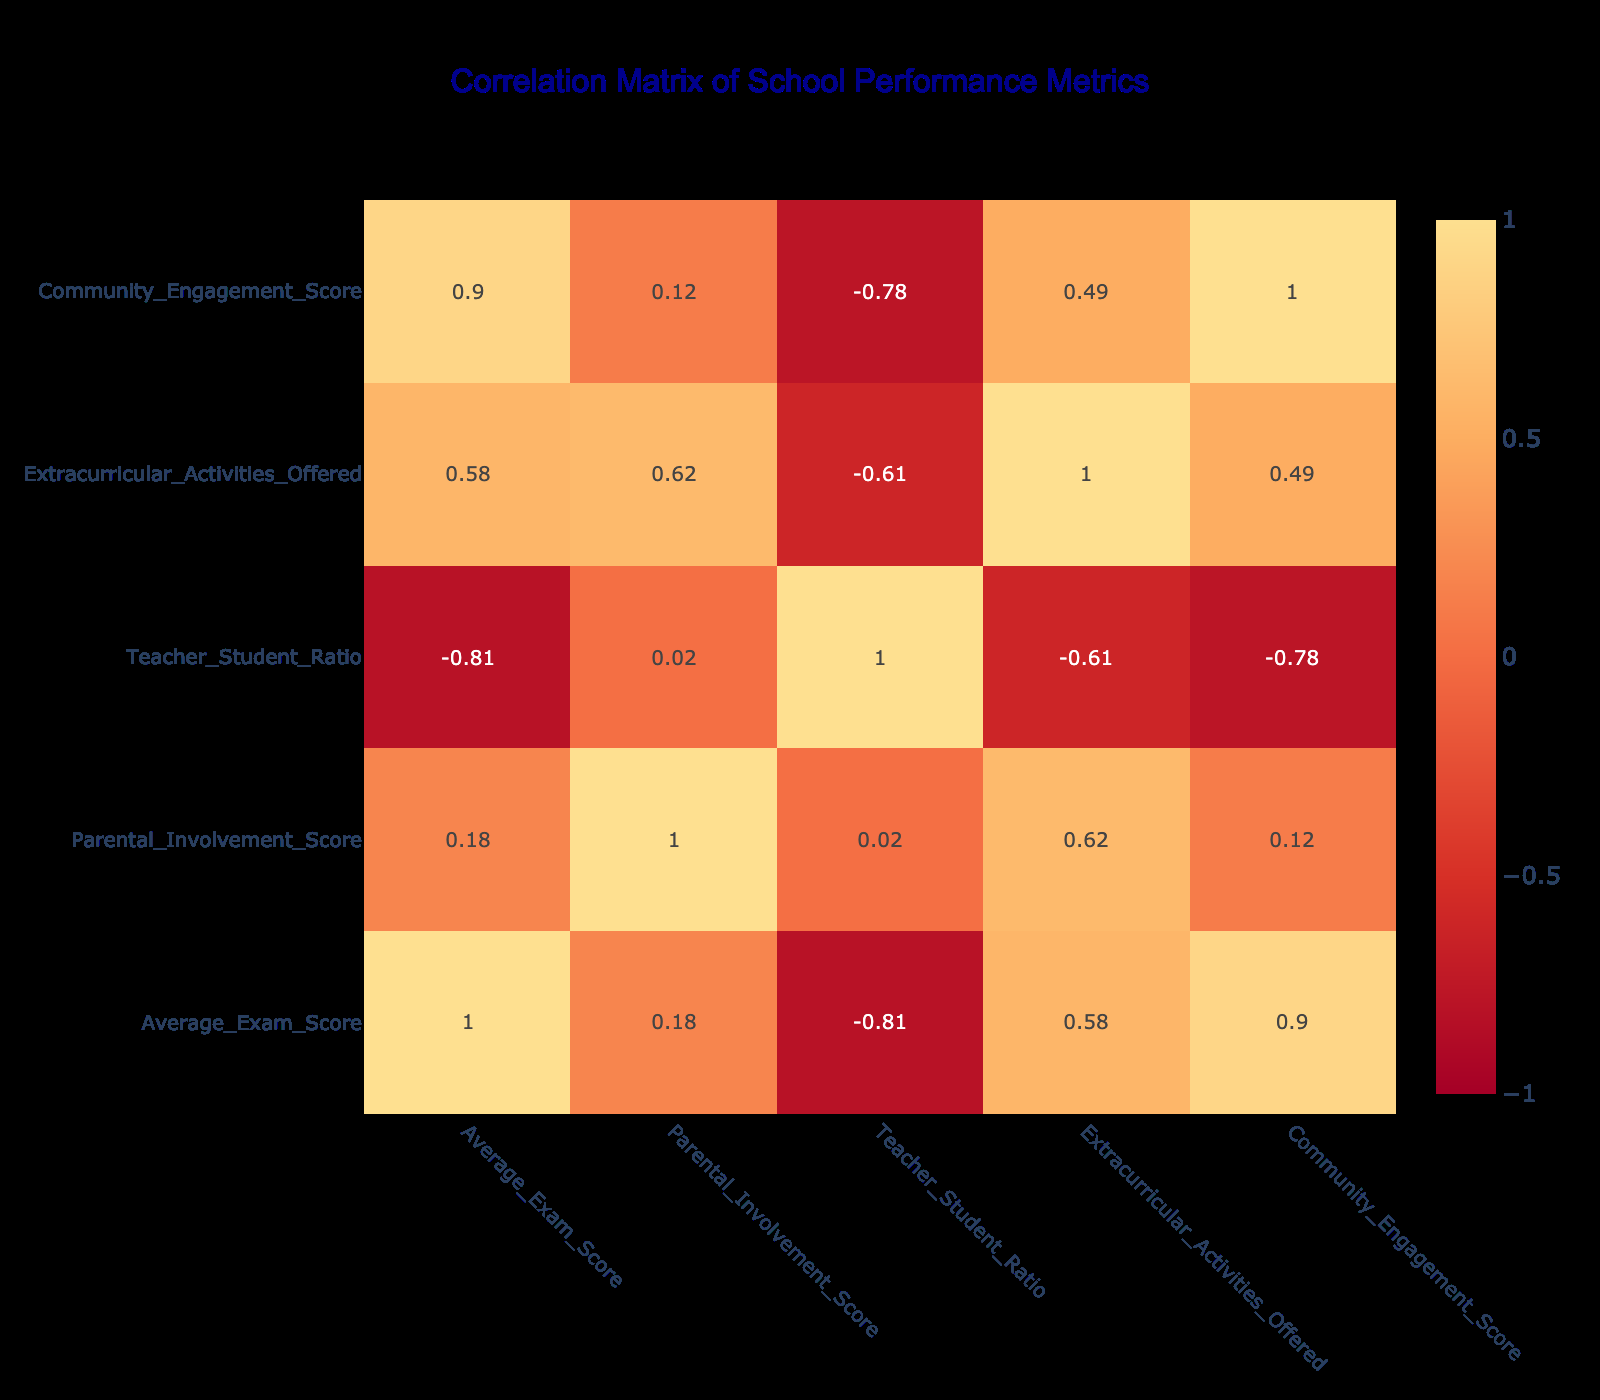What is the highest average exam score among the schools listed? Looking at the "Average_Exam_Score" column, the highest value is 88 for Hayes Primary School.
Answer: 88 Which school has the lowest parental involvement score? By checking the "Parental_Involvement_Score", the lowest score is 60, which belongs to Westwoodside Academy.
Answer: Westwoodside Academy Is there a school that offers more than 10 extracurricular activities? Checking the "Extracurricular_Activities_Offered" column, Hayes Primary School offers 11 activities, which is more than 10.
Answer: Yes What is the average parental involvement score of the schools listed? To find the average, add all the parental involvement scores (75 + 80 + 70 + 60 + 85 + 65 + 78 + 82) = 595, then divide by the number of schools, which is 8: 595/8 = 74.375.
Answer: 74.375 Does Scunthorpe Learning Centre have a better average exam score than Brigg Primary School? Comparing their average exam scores, Scunthorpe Learning Centre has a score of 82 while Brigg Primary School has 78. Since 82 is greater than 78, we conclude that it does indeed have a better score.
Answer: Yes What is the correlation between the average exam score and parental involvement score? The correlation value can be found in the correlation matrix generated; it is approximately 0.24, indicating a weak positive correlation between the average exam score and parental involvement score.
Answer: 0.24 Which school has the best teacher-student ratio? The "Teacher_Student_Ratio" column shows that South Axholme Academy has the best ratio with 12 students per teacher.
Answer: South Axholme Academy If we look at the schools that have a community engagement score of 75 or higher, how many schools are there? The "Community_Engagement_Score" list shows that three schools (South Axholme Academy, Hayes Primary School, and Scunthorpe Learning Centre) have scores 75 or higher.
Answer: 3 